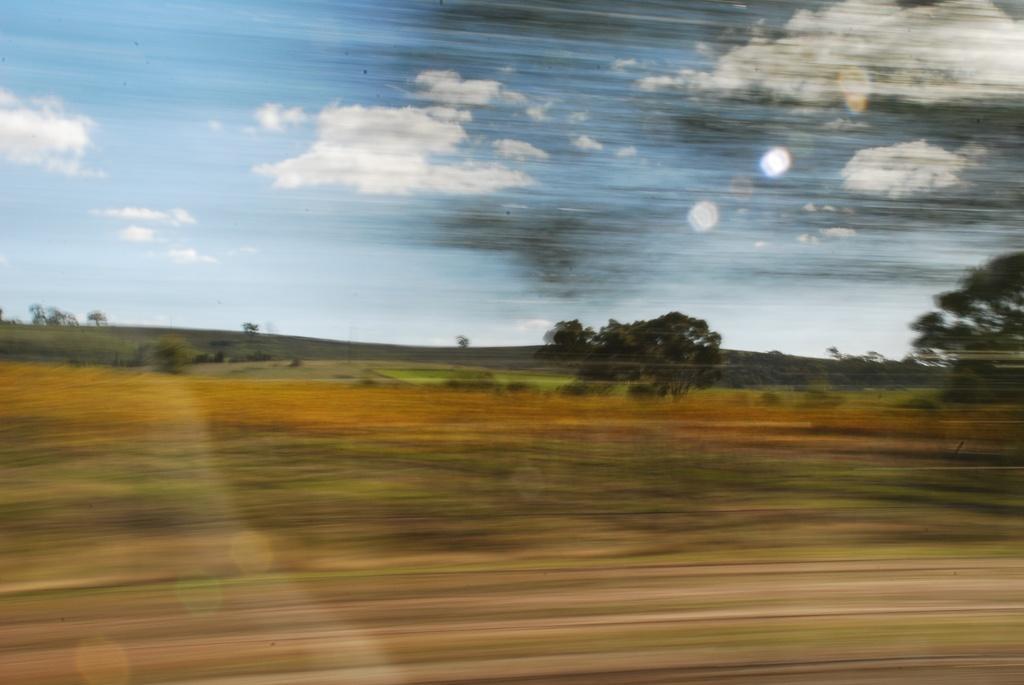In one or two sentences, can you explain what this image depicts? In the foreground of this picture we can see the glass and through the glass we can see the ground, trees, grass and some other objects and in the background we can see the sky with the clouds. 